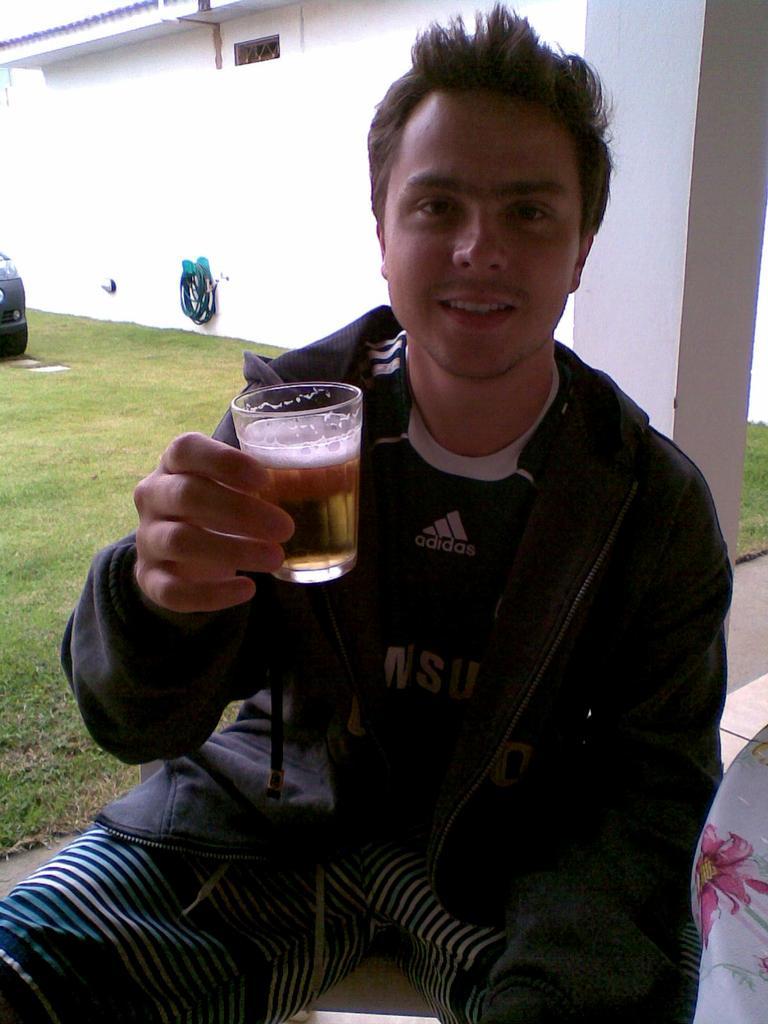How would you summarize this image in a sentence or two? In this picture we can see a man who is holding a glass with his hand. This is grass. Here we can see a pillar and there is a wall. 